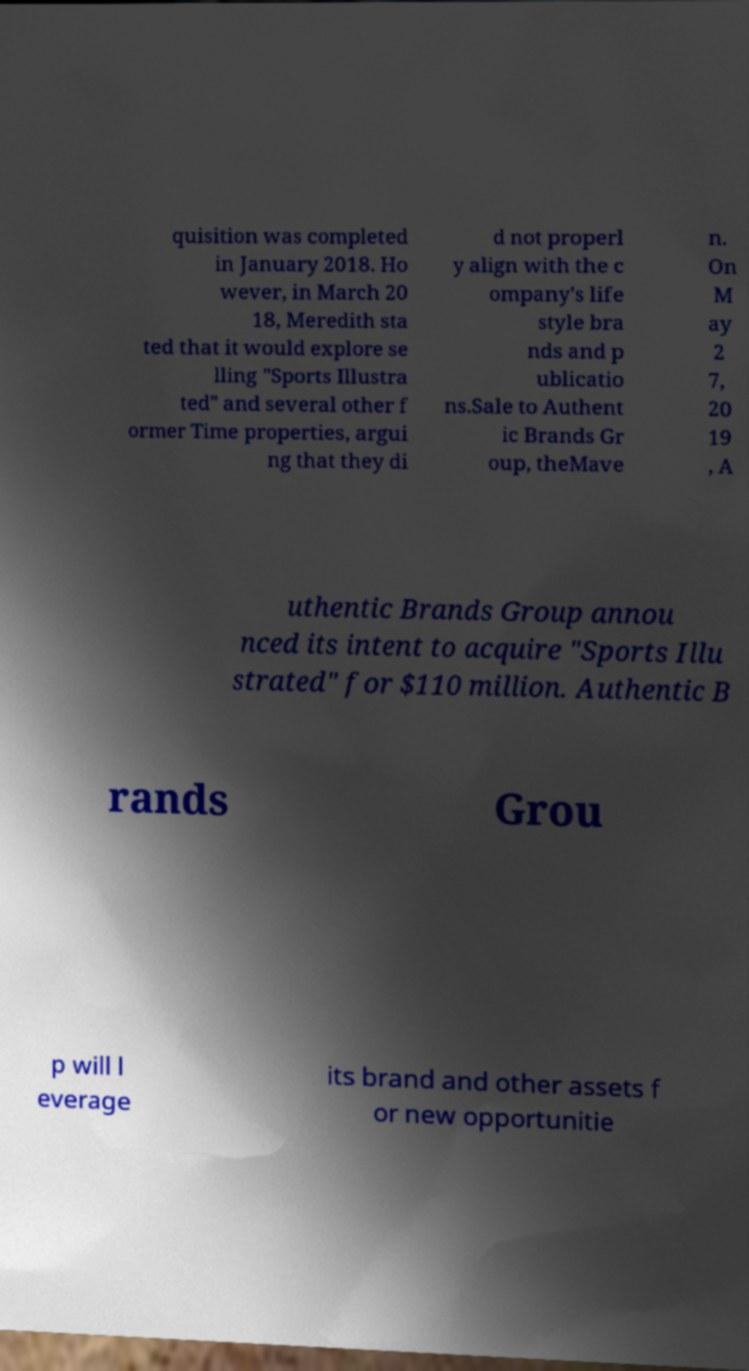Can you accurately transcribe the text from the provided image for me? quisition was completed in January 2018. Ho wever, in March 20 18, Meredith sta ted that it would explore se lling "Sports Illustra ted" and several other f ormer Time properties, argui ng that they di d not properl y align with the c ompany's life style bra nds and p ublicatio ns.Sale to Authent ic Brands Gr oup, theMave n. On M ay 2 7, 20 19 , A uthentic Brands Group annou nced its intent to acquire "Sports Illu strated" for $110 million. Authentic B rands Grou p will l everage its brand and other assets f or new opportunitie 